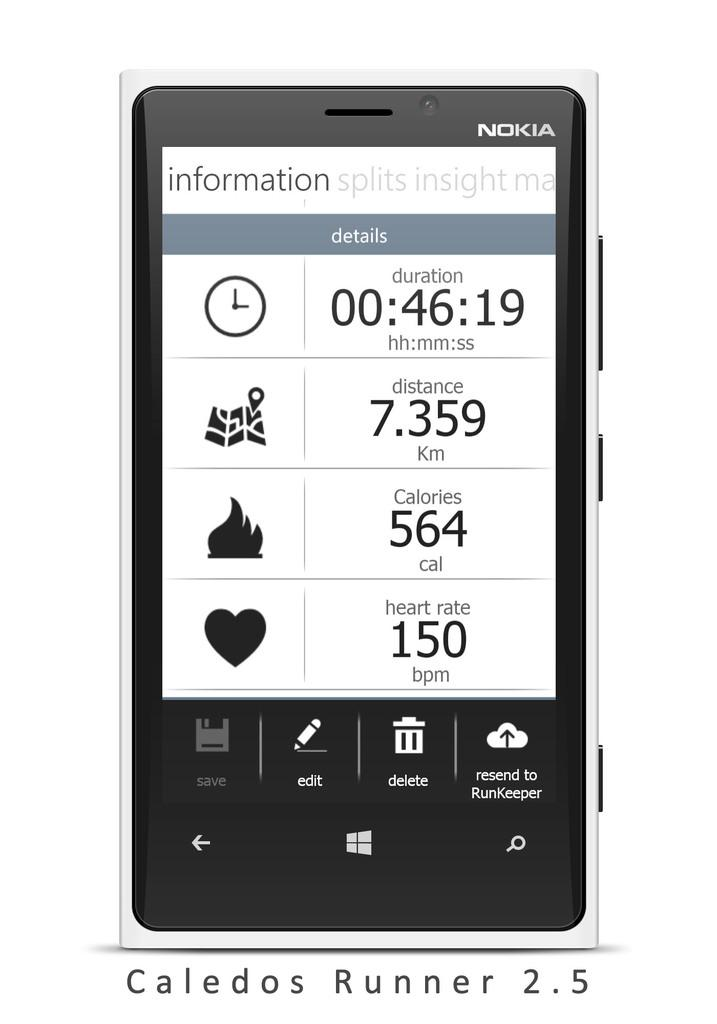<image>
Share a concise interpretation of the image provided. A collection of fitness stats are displayed on a Nokia phone screen. 